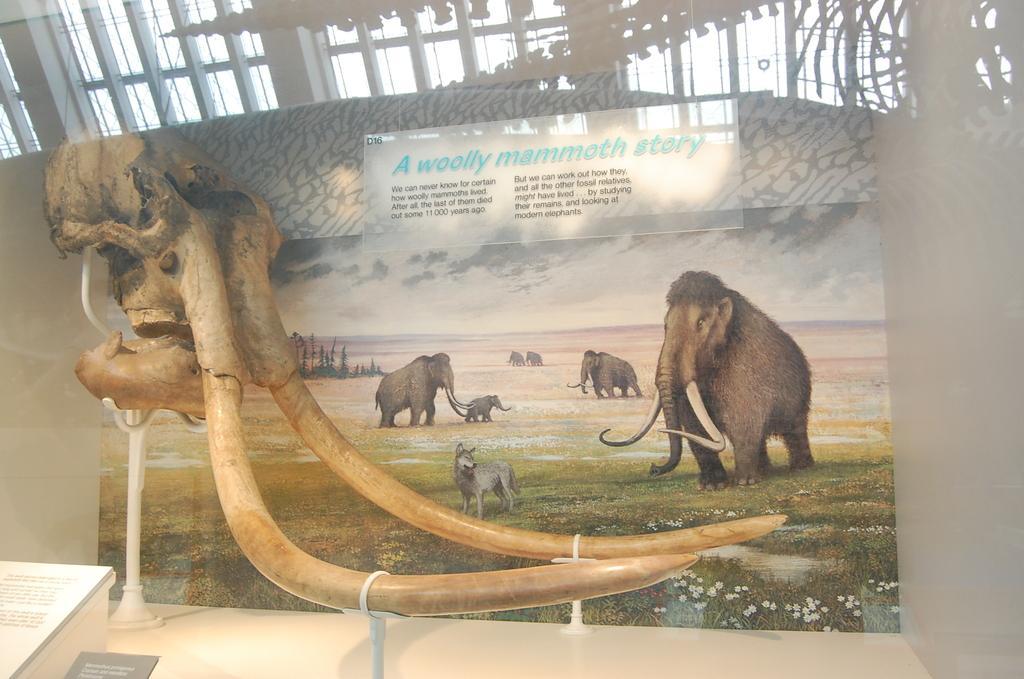In one or two sentences, can you explain what this image depicts? This picture shows a poster. we see elephants and text on the poster and we see tusks of elephant and we see text on the board. 